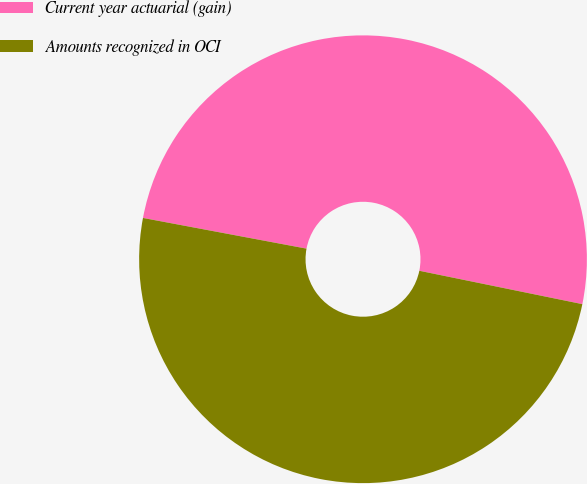Convert chart to OTSL. <chart><loc_0><loc_0><loc_500><loc_500><pie_chart><fcel>Current year actuarial (gain)<fcel>Amounts recognized in OCI<nl><fcel>50.26%<fcel>49.74%<nl></chart> 